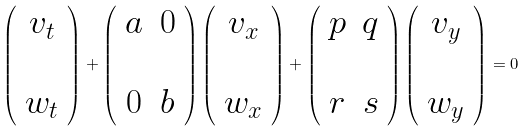Convert formula to latex. <formula><loc_0><loc_0><loc_500><loc_500>\left ( \begin{array} { c } v _ { t } \\ \ \\ w _ { t } \end{array} \right ) + \left ( \begin{array} { c c } a & 0 \\ \ \\ 0 & b \end{array} \right ) \left ( \begin{array} { c } v _ { x } \\ \ \\ w _ { x } \end{array} \right ) + \left ( \begin{array} { c c } p & q \\ \ \\ r & s \end{array} \right ) \left ( \begin{array} { c } v _ { y } \\ \ \\ w _ { y } \end{array} \right ) = 0</formula> 